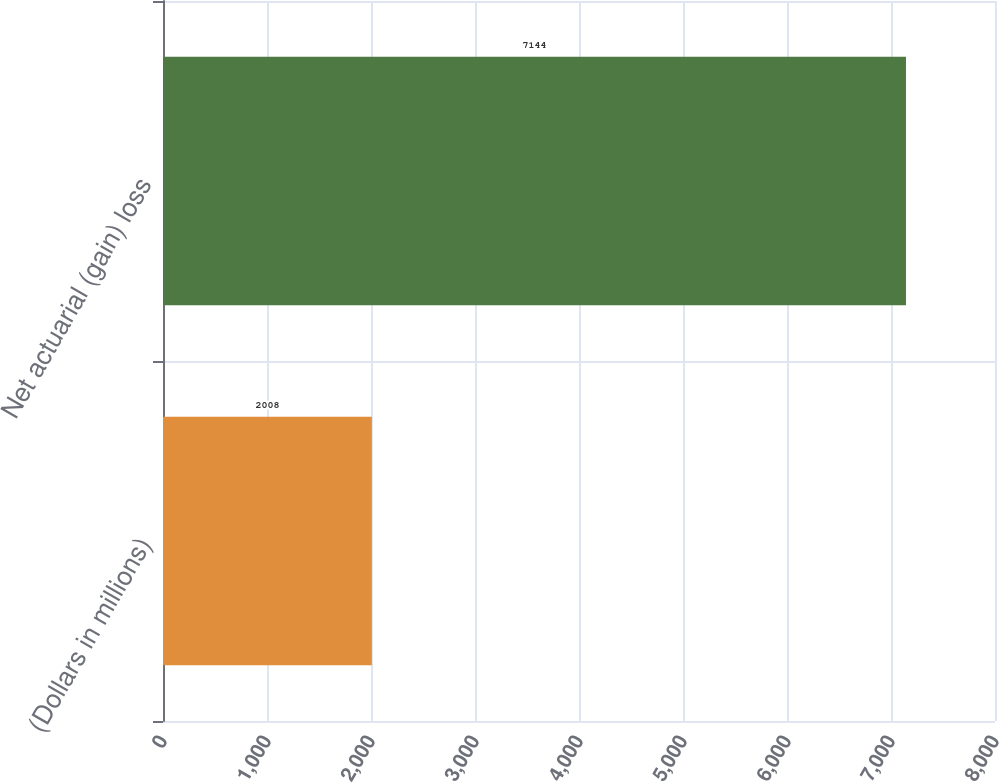Convert chart. <chart><loc_0><loc_0><loc_500><loc_500><bar_chart><fcel>(Dollars in millions)<fcel>Net actuarial (gain) loss<nl><fcel>2008<fcel>7144<nl></chart> 